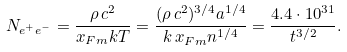Convert formula to latex. <formula><loc_0><loc_0><loc_500><loc_500>N _ { e ^ { + } e ^ { - } } = \frac { \rho \, c ^ { 2 } } { x _ { F m } k T } = \frac { ( \rho \, c ^ { 2 } ) ^ { 3 / 4 } a ^ { 1 / 4 } } { k \, x _ { F m } n ^ { 1 / 4 } } = \frac { 4 . 4 \cdot 1 0 ^ { 3 1 } } { t ^ { 3 / 2 } } .</formula> 